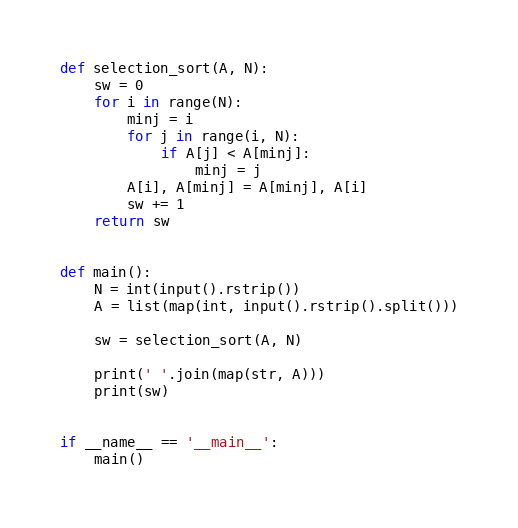Convert code to text. <code><loc_0><loc_0><loc_500><loc_500><_Python_>def selection_sort(A, N):
    sw = 0
    for i in range(N):
        minj = i
        for j in range(i, N):
            if A[j] < A[minj]:
                minj = j
        A[i], A[minj] = A[minj], A[i]
        sw += 1
    return sw


def main():
    N = int(input().rstrip())
    A = list(map(int, input().rstrip().split()))
    
    sw = selection_sort(A, N)
    
    print(' '.join(map(str, A)))
    print(sw)
    
    
if __name__ == '__main__':
    main()</code> 